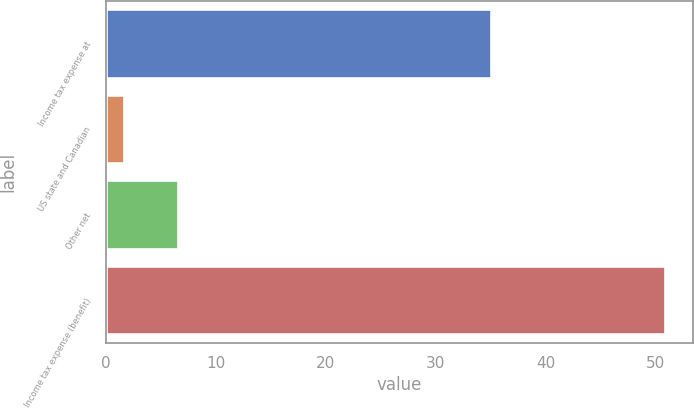Convert chart to OTSL. <chart><loc_0><loc_0><loc_500><loc_500><bar_chart><fcel>Income tax expense at<fcel>US state and Canadian<fcel>Other net<fcel>Income tax expense (benefit)<nl><fcel>35<fcel>1.6<fcel>6.53<fcel>50.9<nl></chart> 